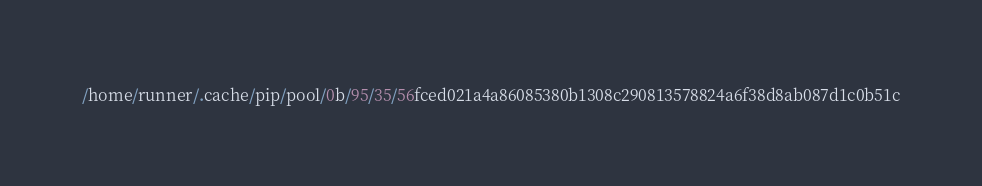<code> <loc_0><loc_0><loc_500><loc_500><_Python_>/home/runner/.cache/pip/pool/0b/95/35/56fced021a4a86085380b1308c290813578824a6f38d8ab087d1c0b51c</code> 